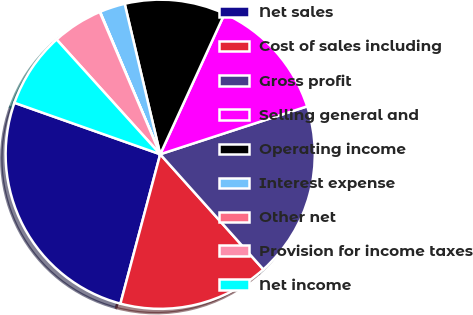Convert chart. <chart><loc_0><loc_0><loc_500><loc_500><pie_chart><fcel>Net sales<fcel>Cost of sales including<fcel>Gross profit<fcel>Selling general and<fcel>Operating income<fcel>Interest expense<fcel>Other net<fcel>Provision for income taxes<fcel>Net income<nl><fcel>26.26%<fcel>15.77%<fcel>18.39%<fcel>13.15%<fcel>10.53%<fcel>2.67%<fcel>0.04%<fcel>5.29%<fcel>7.91%<nl></chart> 